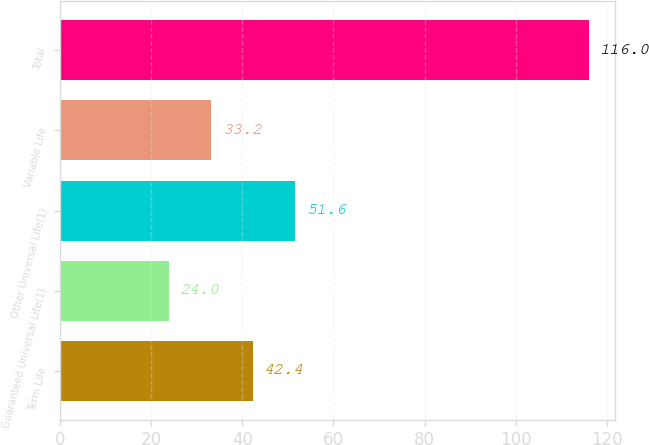<chart> <loc_0><loc_0><loc_500><loc_500><bar_chart><fcel>Term Life<fcel>Guaranteed Universal Life(1)<fcel>Other Universal Life(1)<fcel>Variable Life<fcel>Total<nl><fcel>42.4<fcel>24<fcel>51.6<fcel>33.2<fcel>116<nl></chart> 